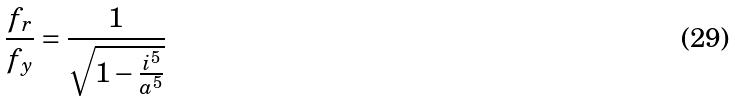Convert formula to latex. <formula><loc_0><loc_0><loc_500><loc_500>\frac { f _ { r } } { f _ { y } } = \frac { 1 } { \sqrt { 1 - \frac { i ^ { 5 } } { a ^ { 5 } } } }</formula> 